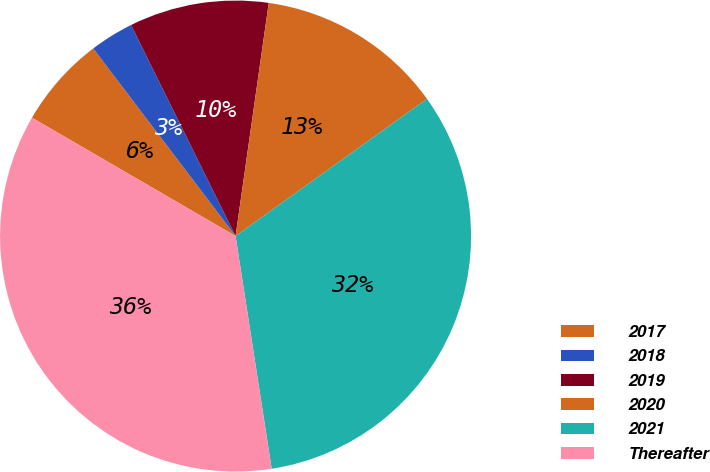Convert chart to OTSL. <chart><loc_0><loc_0><loc_500><loc_500><pie_chart><fcel>2017<fcel>2018<fcel>2019<fcel>2020<fcel>2021<fcel>Thereafter<nl><fcel>6.29%<fcel>3.01%<fcel>9.57%<fcel>12.85%<fcel>32.45%<fcel>35.83%<nl></chart> 